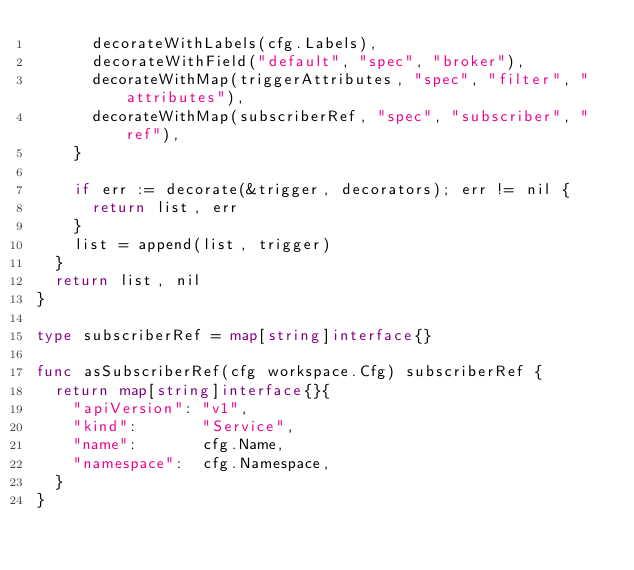<code> <loc_0><loc_0><loc_500><loc_500><_Go_>			decorateWithLabels(cfg.Labels),
			decorateWithField("default", "spec", "broker"),
			decorateWithMap(triggerAttributes, "spec", "filter", "attributes"),
			decorateWithMap(subscriberRef, "spec", "subscriber", "ref"),
		}

		if err := decorate(&trigger, decorators); err != nil {
			return list, err
		}
		list = append(list, trigger)
	}
	return list, nil
}

type subscriberRef = map[string]interface{}

func asSubscriberRef(cfg workspace.Cfg) subscriberRef {
	return map[string]interface{}{
		"apiVersion": "v1",
		"kind":       "Service",
		"name":       cfg.Name,
		"namespace":  cfg.Namespace,
	}
}
</code> 